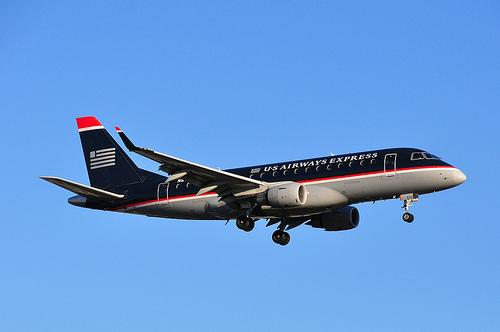Describe the overall scene shown in the image. A blue, gray, and red airplane with flag symbol on the tail, engines, and tires is in the sky with blue sky in the background. Perform complex reasoning and speculate why the wing tips are raised. The wing tips are likely raised to improve the airplane's aerodynamic performance, reduce drag, and increase fuel efficiency. Identify and describe the sentiment associated with the image. The image presents a neutral or positive sentiment, as it shows an airplane flying in the blue sky, which may evoke feelings of travel and adventure. What color are the airplane's wheels, and are they up or down? The airplane's wheels are black in color and are lowered, with the front wheels being down. What are the words written on the side of the plane? The words "US Airways Express" are written on the side of the plane. Count and identify the various components present in the airplane. There are wings, tail, 3 pairs of tires, 2 engines, 2 doors, flag icon, nose, and several windows on the side and front. Analyze the image and describe the position of the airplane's wing tips. The wing tips of the airplane are raised and the tip of the right wing is red in color. Describe the interaction between the airplane's components. The wings provide lift for the airplane, engines propel it forward, tires support takeoff and landing, doors allow entry and exit, and windows provide visibility for passengers and pilots. Identify and describe the flag symbol on the airplane's tail. There is a flag symbol drawn on the tail of the airplane, which is a representation of the airline's identity or nationality. Can you see the two pilots inside the cockpit through the windows on the front of the plane? The image provides information on the positions and sizes of the windows on the front of the plane, but not about any figures inside the cockpit. So, asking about the pilots is misleading. Are the tires on the bottom of the plane square-shaped? While the image provides position and size information about the tires, it does not specify the shape of the tires. The question about square-shaped tires is, therefore, misleading. Is there a blinking light on the wing tip of the plane? The image does not provide any information about a blinking light on the wing tip of the plane. Instead, it only mentions the positions and sizes of the wings and the wing tips. Is the flag symbol on the tail green and yellow? The instruction is suggesting the flag symbol has green and yellow colors, but the image does not provide any information about its colors. Thus, it's misleading. Are there letters on side of the plane that spell "HELLO" in orange color? Although there are words on the side of the plane, the image does not provide enough detail to determine if the letters spell "HELLO" or if they are orange in color. Is the nose of the plane painted with a picture of a lion? There is no information about any paintings or pictures on the nose of the plane in the image, making the instruction misleading. 